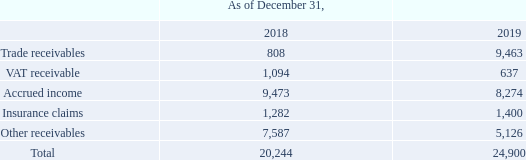GasLog Ltd. and its Subsidiaries
Notes to the consolidated financial statements (Continued)
For the years ended December 31, 2017, 2018 and 2019
(All amounts expressed in thousands of U.S. Dollars, except share and per share data)
9. Trade and Other Receivables
Trade and other receivables consist of the following:
Trade and other receivables are amounts due from third parties for services performed in the ordinary course of business. They are generally due for settlement immediately and therefore are all classified as current. Trade and other receivables are recognized initially at the amount of consideration that is unconditional unless they contain certain significant financing components, at which point they are recognized at fair value. The Group holds the trade receivables with the objective to collect the contractual cash flows and therefore measures them subsequently at amortized cost using the effective interest rate method.
Accrued income represents net revenues receivable from charterers, which have not yet been invoiced; all other amounts not yet invoiced are included under Other receivables.
As of December 31, 2018 and 2019 no allowance for expected credit losses was recorded.
What are the components of trade and other receivables? Trade receivables, vat receivable, accrued income, insurance claims, other receivables. Why does the Group hold the trade receivables? The group holds the trade receivables with the objective to collect the contractual cash flows. What does accrued income represent? Accrued income represents net revenues receivable from charterers, which have not yet been invoiced. In which year was the insurance claims higher? 1,400 > 1,282
Answer: 2019. What was the change in trade receivables from 2018 to 2019?
Answer scale should be: thousand. 9,463 - 808 
Answer: 8655. What was the percentage change in total receivables from 2018 to 2019?
Answer scale should be: percent. (24,900 - 20,244)/20,244 
Answer: 23. 